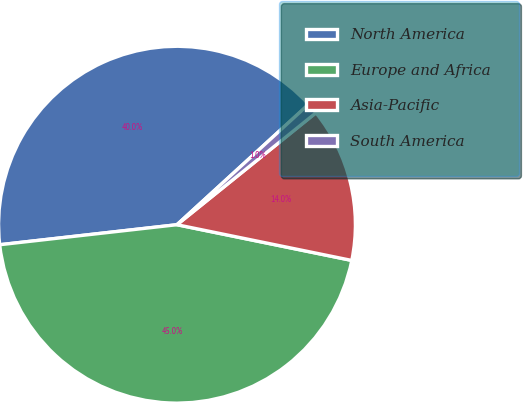Convert chart to OTSL. <chart><loc_0><loc_0><loc_500><loc_500><pie_chart><fcel>North America<fcel>Europe and Africa<fcel>Asia-Pacific<fcel>South America<nl><fcel>40.0%<fcel>45.0%<fcel>14.0%<fcel>1.0%<nl></chart> 